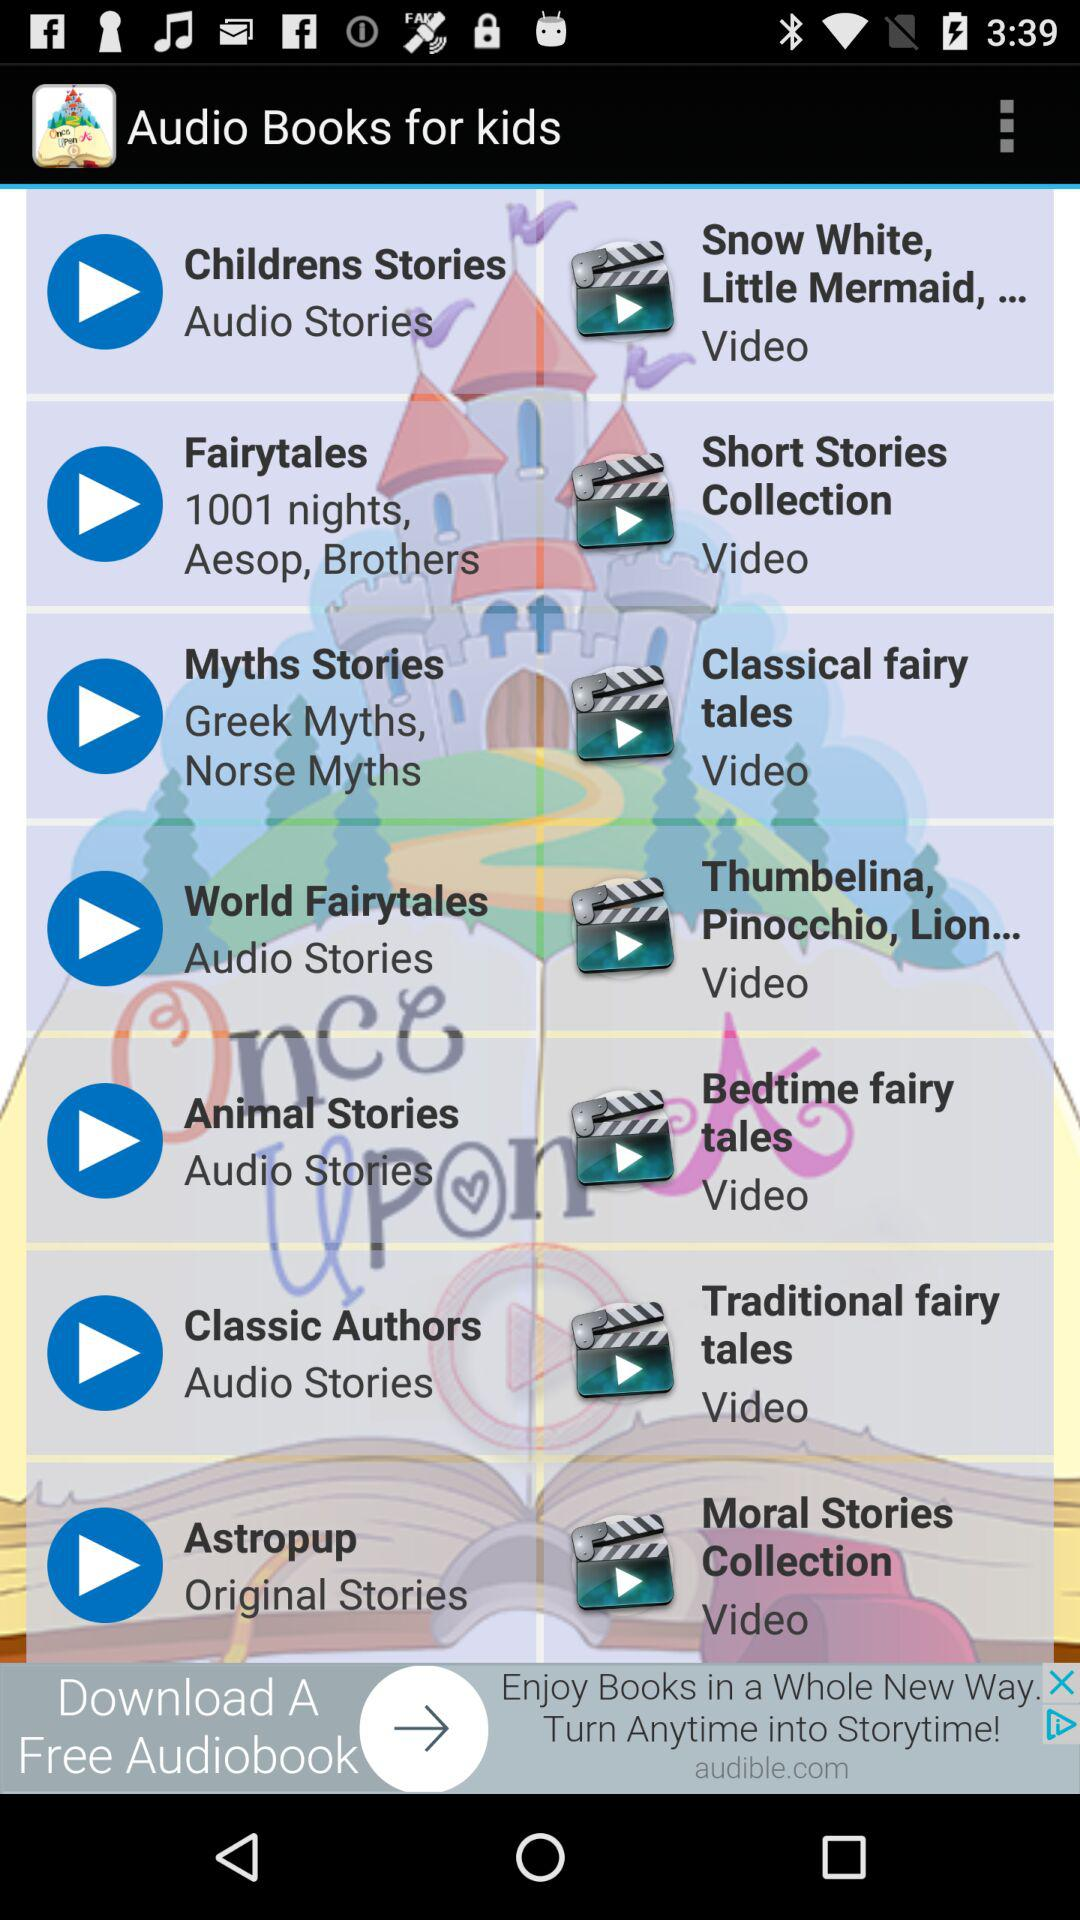Which are the different videos? The different videos are "Snow White, Little Mermaid,...", "Short Stories Collection", "Classical fairy tales", "Thumbelina, Pinocchio, Lion...", "Bedtime fairy tales", "Traditional fairy tales" and "Moral Stories Collection". 